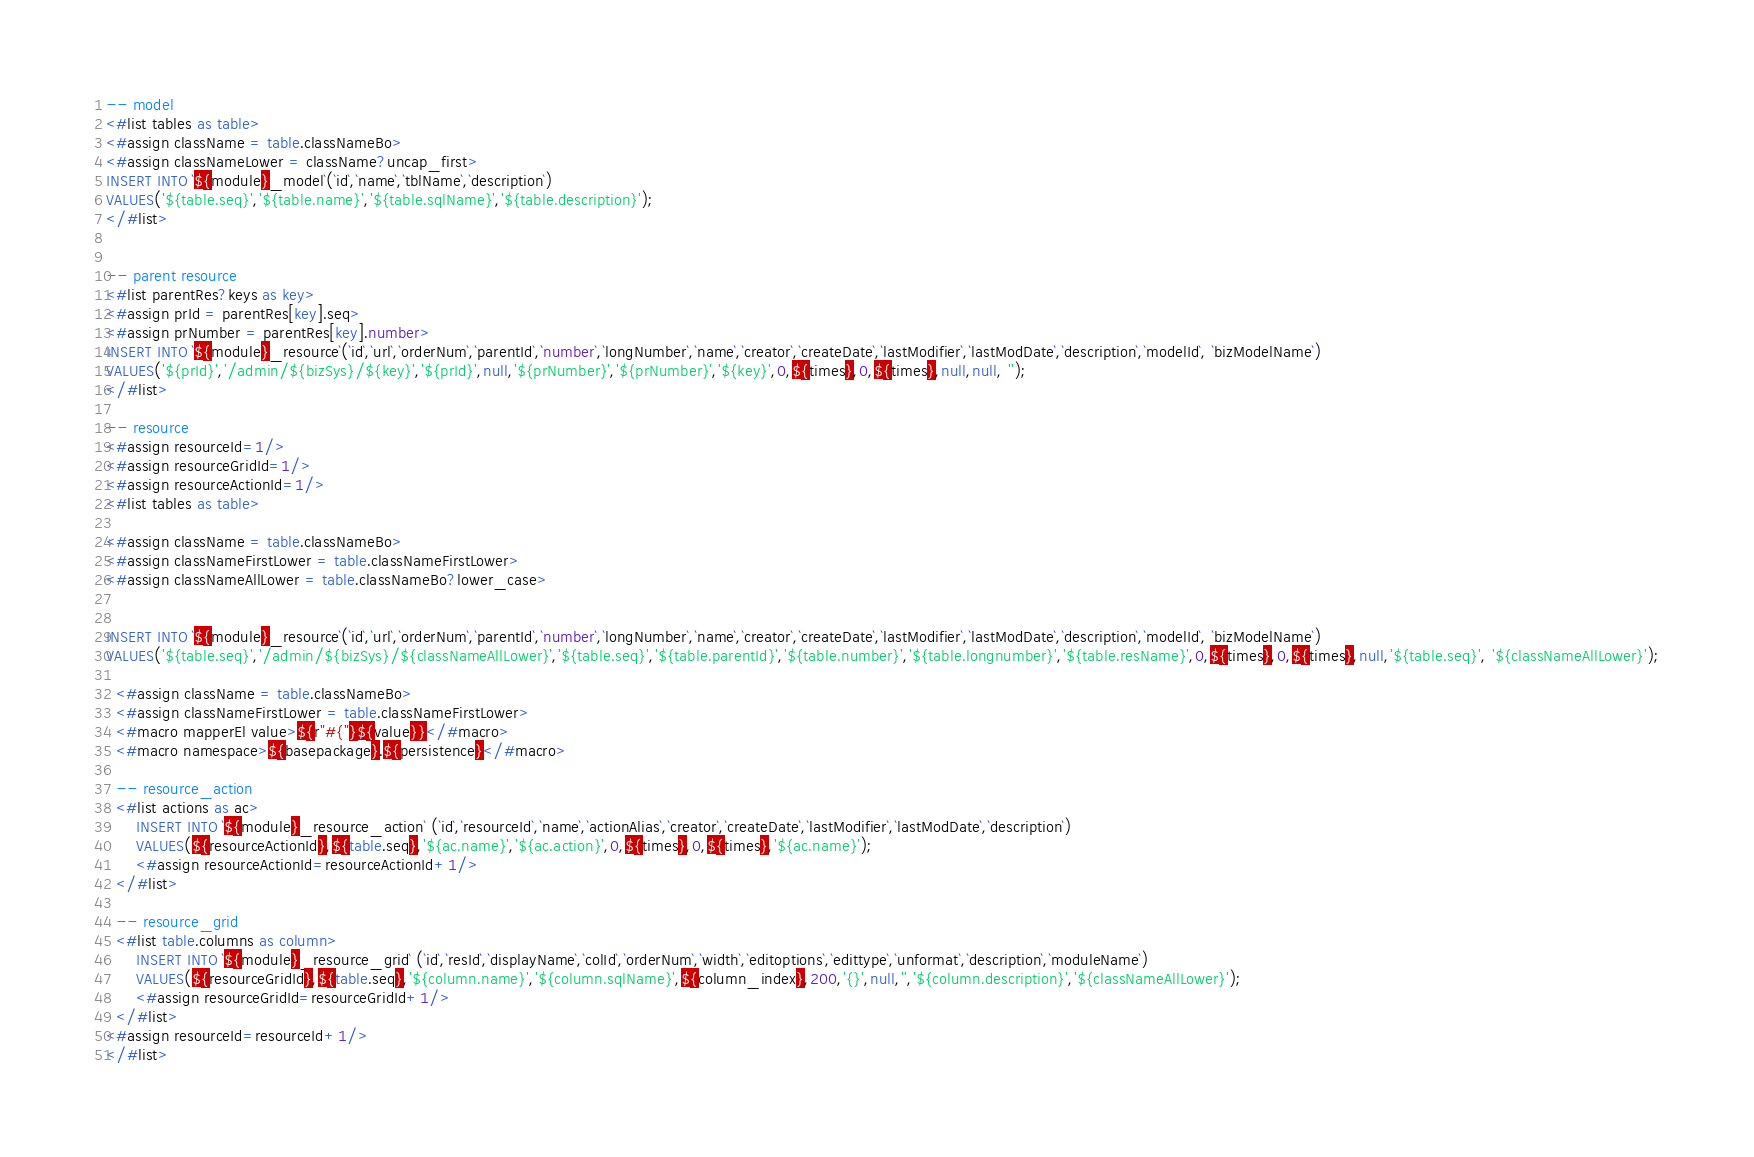<code> <loc_0><loc_0><loc_500><loc_500><_SQL_>-- model
<#list tables as table>
<#assign className = table.classNameBo>
<#assign classNameLower = className?uncap_first>
INSERT INTO `${module}_model`(`id`,`name`,`tblName`,`description`)
VALUES('${table.seq}','${table.name}','${table.sqlName}','${table.description}');
</#list>


-- parent resource
<#list parentRes?keys as key>
<#assign prId = parentRes[key].seq>
<#assign prNumber = parentRes[key].number>
INSERT INTO `${module}_resource`(`id`,`url`,`orderNum`,`parentId`,`number`,`longNumber`,`name`,`creator`,`createDate`,`lastModifier`,`lastModDate`,`description`,`modelId`, `bizModelName`)
VALUES('${prId}','/admin/${bizSys}/${key}','${prId}',null,'${prNumber}','${prNumber}','${key}',0,${times},0,${times},null,null, '');
</#list>

-- resource
<#assign resourceId=1/>
<#assign resourceGridId=1/>
<#assign resourceActionId=1/>
<#list tables as table>

<#assign className = table.classNameBo>
<#assign classNameFirstLower = table.classNameFirstLower>
<#assign classNameAllLower = table.classNameBo?lower_case>


INSERT INTO `${module}_resource`(`id`,`url`,`orderNum`,`parentId`,`number`,`longNumber`,`name`,`creator`,`createDate`,`lastModifier`,`lastModDate`,`description`,`modelId`, `bizModelName`)
VALUES('${table.seq}','/admin/${bizSys}/${classNameAllLower}','${table.seq}','${table.parentId}','${table.number}','${table.longnumber}','${table.resName}',0,${times},0,${times},null,'${table.seq}', '${classNameAllLower}');

  <#assign className = table.classNameBo>
  <#assign classNameFirstLower = table.classNameFirstLower>
  <#macro mapperEl value>${r"#{"}${value}}</#macro>
  <#macro namespace>${basepackage}.${persistence}</#macro>

  -- resource_action
  <#list actions as ac>
      INSERT INTO `${module}_resource_action` (`id`,`resourceId`,`name`,`actionAlias`,`creator`,`createDate`,`lastModifier`,`lastModDate`,`description`)
      VALUES(${resourceActionId},${table.seq},'${ac.name}','${ac.action}',0,${times},0,${times},'${ac.name}');
      <#assign resourceActionId=resourceActionId+1/>
  </#list>

  -- resource_grid
  <#list table.columns as column>
      INSERT INTO `${module}_resource_grid` (`id`,`resId`,`displayName`,`colId`,`orderNum`,`width`,`editoptions`,`edittype`,`unformat`,`description`,`moduleName`)
      VALUES(${resourceGridId},${table.seq},'${column.name}','${column.sqlName}',${column_index},200,'{}',null,'','${column.description}','${classNameAllLower}');
      <#assign resourceGridId=resourceGridId+1/>
  </#list>
<#assign resourceId=resourceId+1/>
</#list></code> 